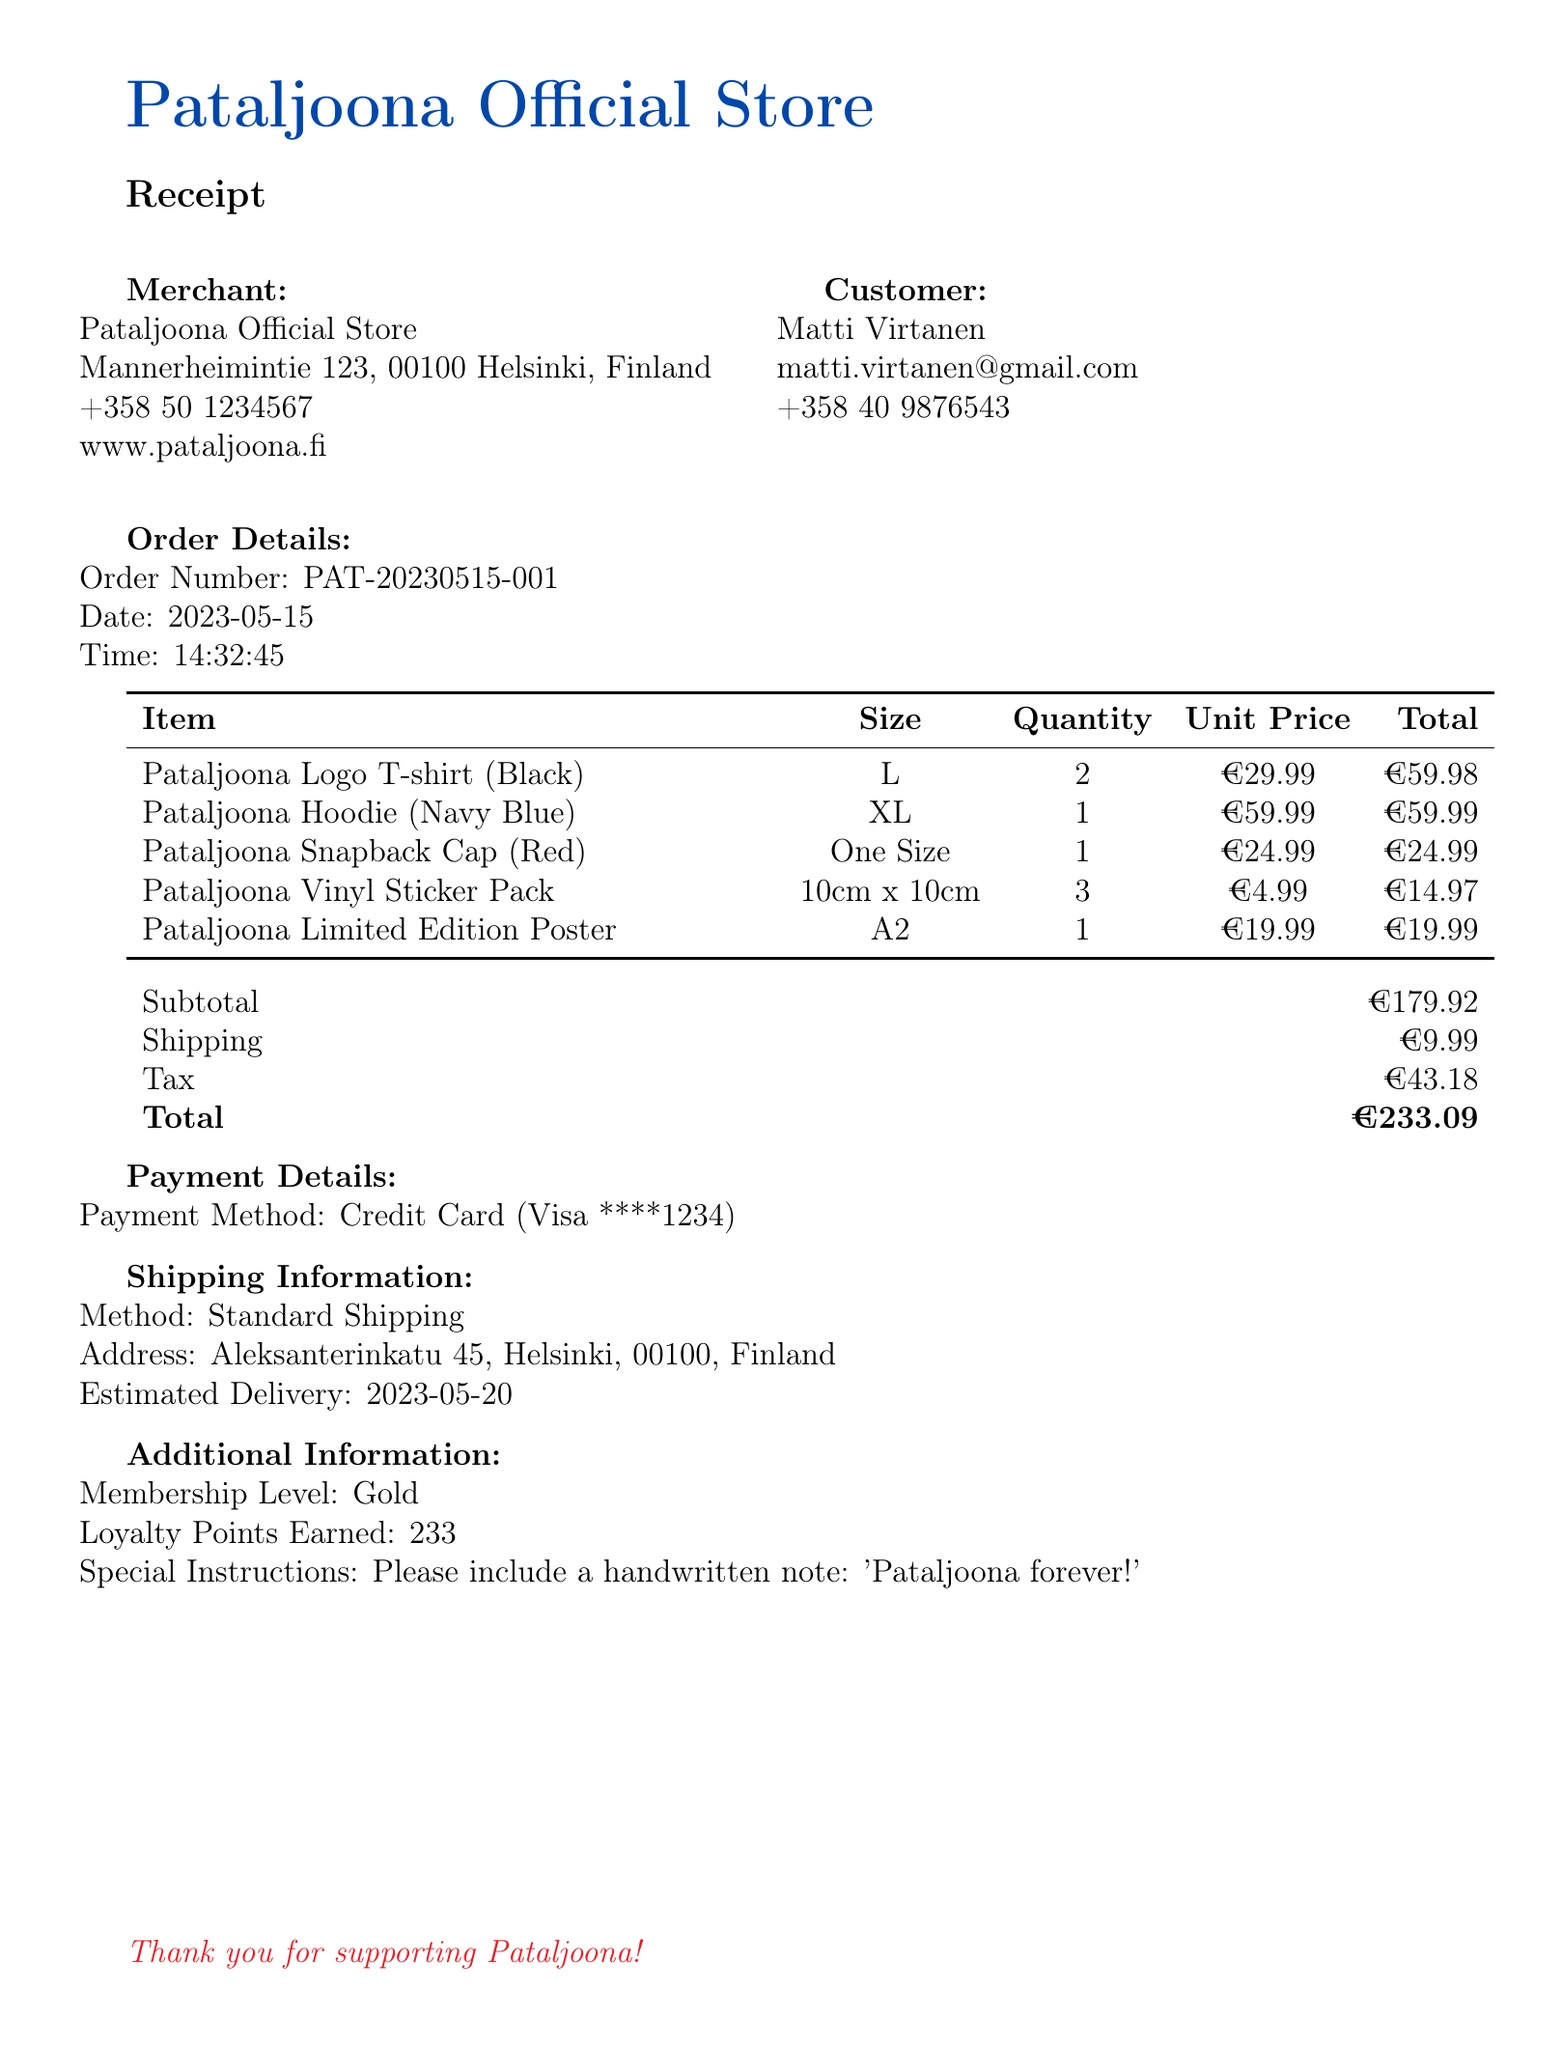What is the name of the merchant? The merchant's name is provided at the beginning of the document under merchant information.
Answer: Pataljoona Official Store What is the order number? The order number is specified in the order details section of the document.
Answer: PAT-20230515-001 What was the total amount charged? The total amount charged is the final amount listed in the payment details.
Answer: €233.09 How many Pataljoona Vinyl Sticker Packs were purchased? The quantity of each item is listed in the items section of the document.
Answer: 3 What special instruction was included with the order? The special instruction is mentioned under additional information.
Answer: Please include a handwritten note: 'Pataljoona forever!' What is the estimated delivery date? The estimated delivery date can be found in the shipping information section.
Answer: 2023-05-20 How many loyalty points were earned? The loyalty points earned are included in the additional information section of the document.
Answer: 233 What size is the Pataljoona Hoodie? The size of each item is provided in the items section of the document.
Answer: XL What payment method was used? The payment method is listed in the payment details section.
Answer: Credit Card 